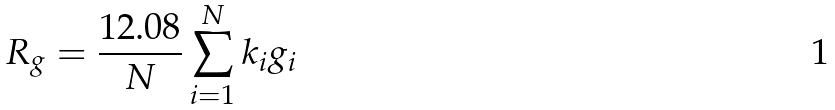Convert formula to latex. <formula><loc_0><loc_0><loc_500><loc_500>R _ { g } = \frac { 1 2 . 0 8 } { N } \sum _ { i = 1 } ^ { N } k _ { i } g _ { i }</formula> 